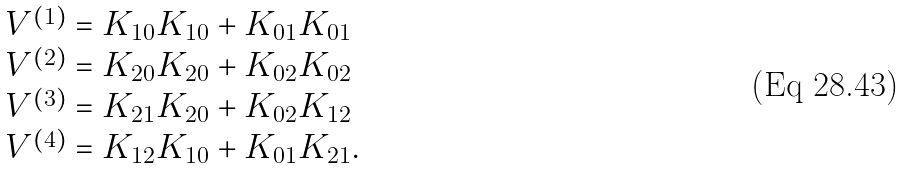<formula> <loc_0><loc_0><loc_500><loc_500>\begin{array} { l } V ^ { ( 1 ) } = K _ { 1 0 } K _ { 1 0 } + K _ { 0 1 } K _ { 0 1 } \\ V ^ { ( 2 ) } = K _ { 2 0 } K _ { 2 0 } + K _ { 0 2 } K _ { 0 2 } \\ V ^ { ( 3 ) } = K _ { 2 1 } K _ { 2 0 } + K _ { 0 2 } K _ { 1 2 } \\ V ^ { ( 4 ) } = K _ { 1 2 } K _ { 1 0 } + K _ { 0 1 } K _ { 2 1 } . \end{array}</formula> 